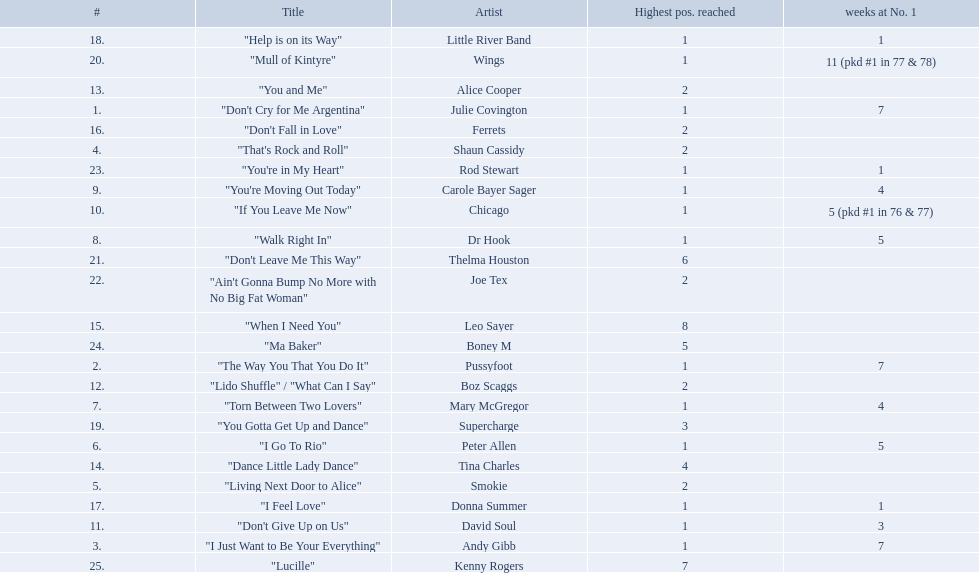How long is the longest amount of time spent at number 1? 11 (pkd #1 in 77 & 78). What song spent 11 weeks at number 1? "Mull of Kintyre". What band had a number 1 hit with this song? Wings. 